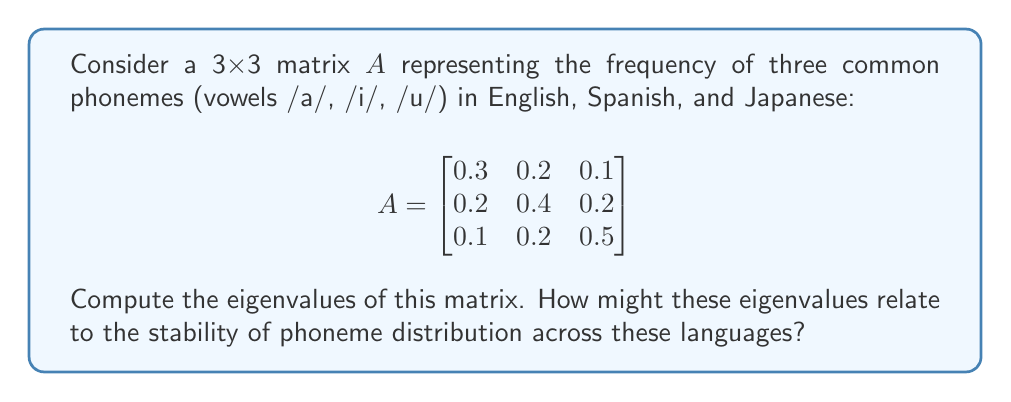Can you solve this math problem? To find the eigenvalues of matrix $A$, we need to solve the characteristic equation:

1) First, we set up the equation $\det(A - \lambda I) = 0$, where $I$ is the 3x3 identity matrix:

   $$\det\begin{bmatrix}
   0.3-\lambda & 0.2 & 0.1 \\
   0.2 & 0.4-\lambda & 0.2 \\
   0.1 & 0.2 & 0.5-\lambda
   \end{bmatrix} = 0$$

2) Expand the determinant:
   
   $(0.3-\lambda)[(0.4-\lambda)(0.5-\lambda) - 0.04] - 0.2[0.2(0.5-\lambda) - 0.02] + 0.1[0.2(0.2) - (0.4-\lambda)(0.1)] = 0$

3) Simplify:

   $(0.3-\lambda)(0.2-\lambda^2+0.9\lambda) - 0.2(0.1-0.5\lambda) + 0.1(0.04-0.04+0.1\lambda) = 0$

4) Expand further:

   $0.06-0.3\lambda-0.06\lambda+0.3\lambda^2+0.27\lambda-0.27\lambda^2 - 0.02+0.1\lambda + 0.004+0.01\lambda = 0$

5) Collect terms:

   $0.03\lambda^2 - 0.22\lambda + 0.044 = 0$

6) Solve this quadratic equation using the quadratic formula:

   $\lambda = \frac{0.22 \pm \sqrt{0.22^2 - 4(0.03)(0.044)}}{2(0.03)}$

7) Simplify:

   $\lambda = \frac{0.22 \pm \sqrt{0.0484 - 0.00528}}{0.06} = \frac{0.22 \pm \sqrt{0.04312}}{0.06}$

8) Calculate the final values:

   $\lambda_1 \approx 1.0$
   $\lambda_2 \approx 0.2$
   $\lambda_3 \approx 0.0$

The largest eigenvalue (1.0) suggests a dominant pattern in the phoneme distribution, which could indicate a stable, shared feature across these languages. The smaller eigenvalues might represent language-specific variations in phoneme frequencies.
Answer: $\lambda_1 \approx 1.0$, $\lambda_2 \approx 0.2$, $\lambda_3 \approx 0.0$ 